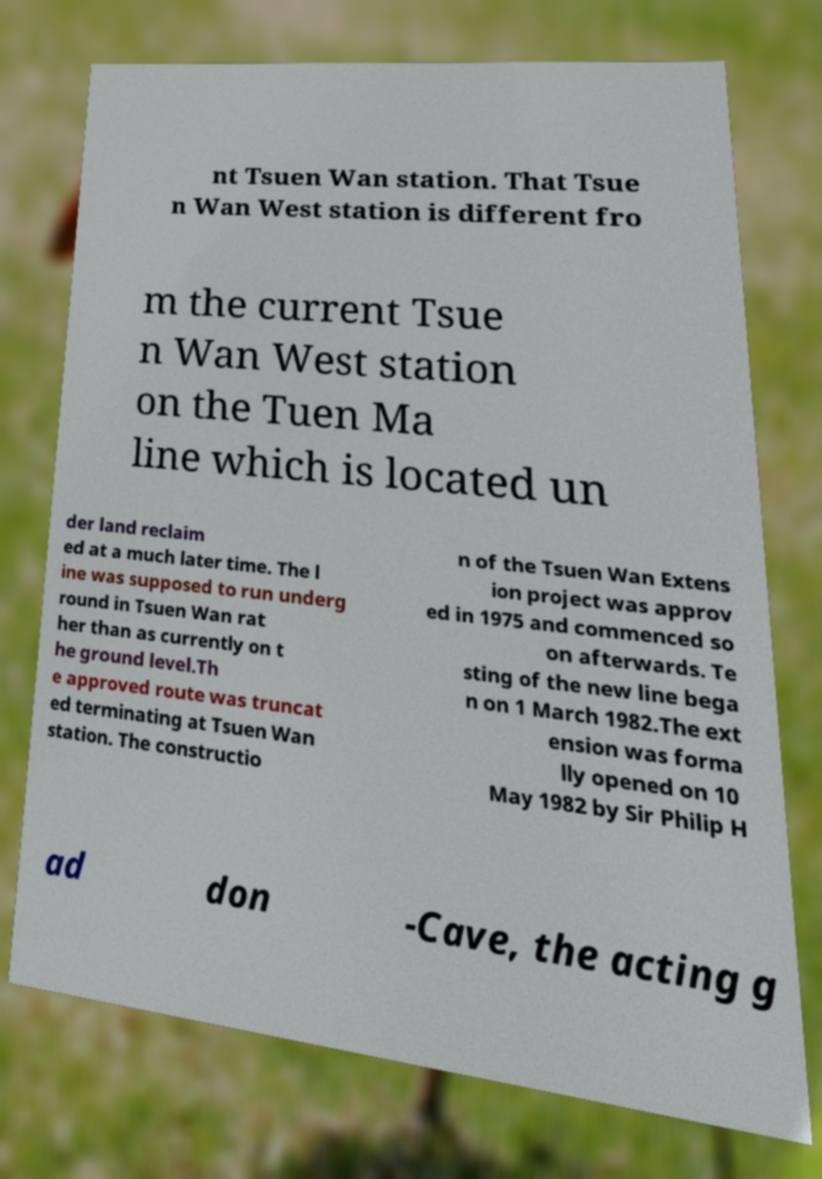I need the written content from this picture converted into text. Can you do that? nt Tsuen Wan station. That Tsue n Wan West station is different fro m the current Tsue n Wan West station on the Tuen Ma line which is located un der land reclaim ed at a much later time. The l ine was supposed to run underg round in Tsuen Wan rat her than as currently on t he ground level.Th e approved route was truncat ed terminating at Tsuen Wan station. The constructio n of the Tsuen Wan Extens ion project was approv ed in 1975 and commenced so on afterwards. Te sting of the new line bega n on 1 March 1982.The ext ension was forma lly opened on 10 May 1982 by Sir Philip H ad don -Cave, the acting g 